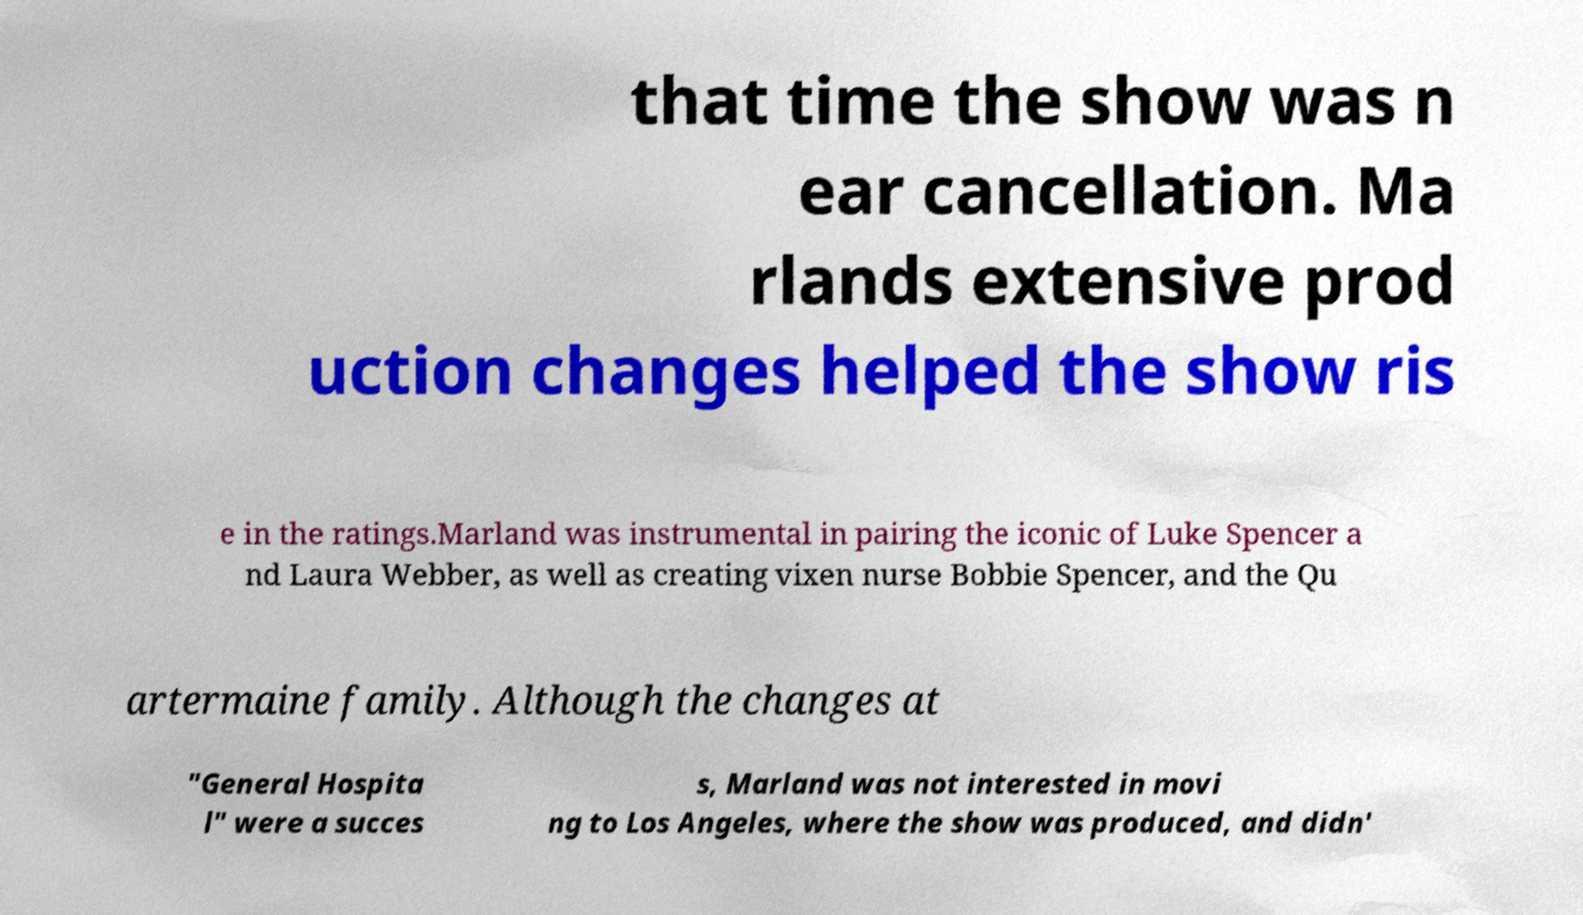Can you read and provide the text displayed in the image?This photo seems to have some interesting text. Can you extract and type it out for me? that time the show was n ear cancellation. Ma rlands extensive prod uction changes helped the show ris e in the ratings.Marland was instrumental in pairing the iconic of Luke Spencer a nd Laura Webber, as well as creating vixen nurse Bobbie Spencer, and the Qu artermaine family. Although the changes at "General Hospita l" were a succes s, Marland was not interested in movi ng to Los Angeles, where the show was produced, and didn' 